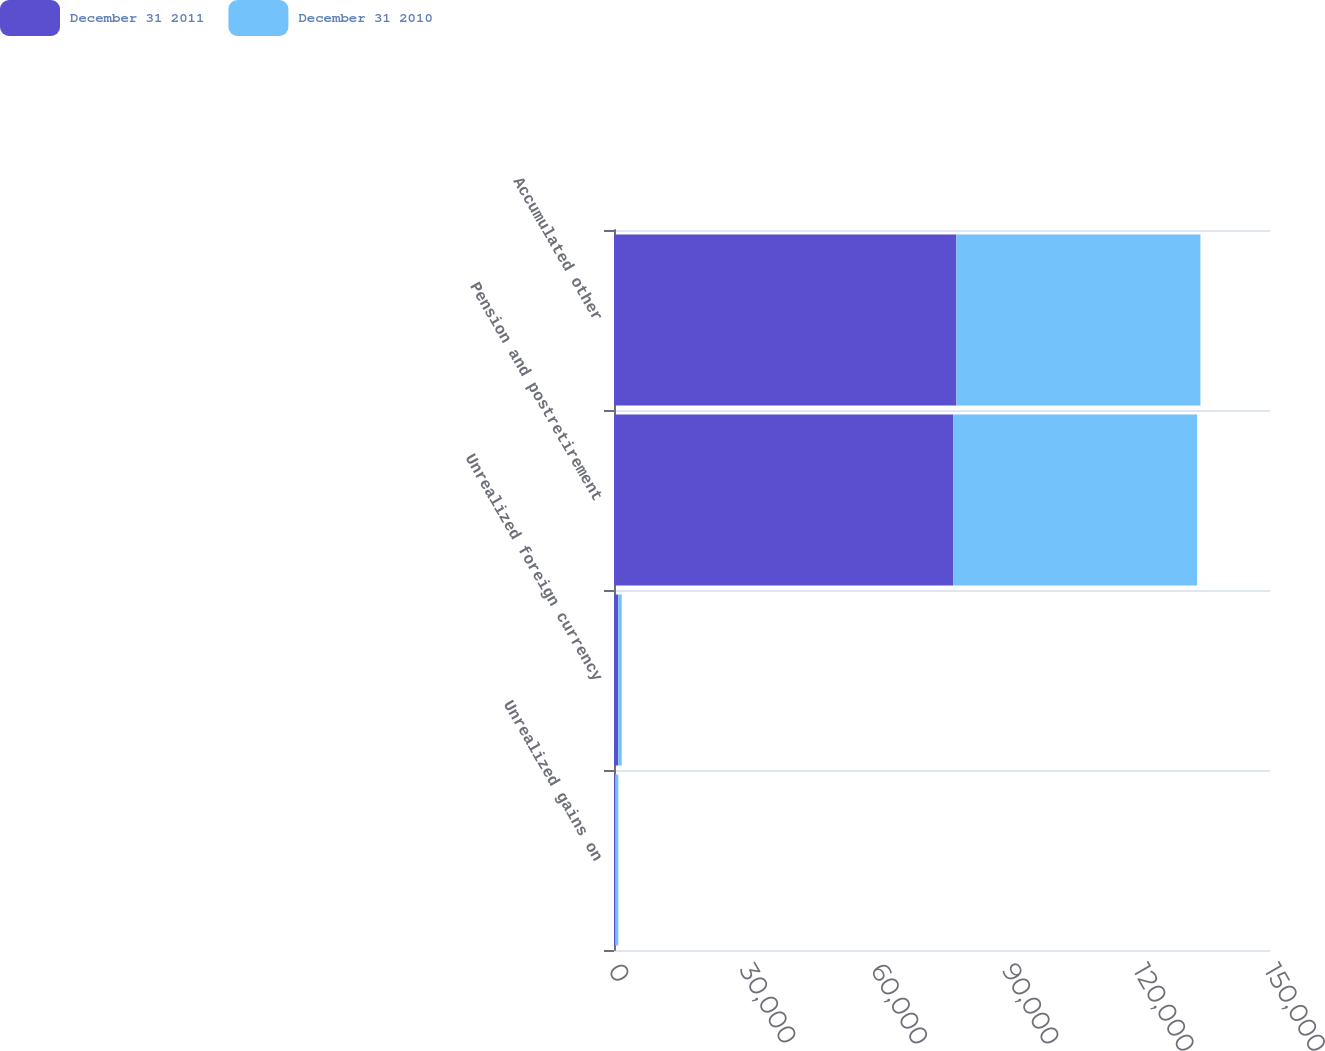<chart> <loc_0><loc_0><loc_500><loc_500><stacked_bar_chart><ecel><fcel>Unrealized gains on<fcel>Unrealized foreign currency<fcel>Pension and postretirement<fcel>Accumulated other<nl><fcel>December 31 2011<fcel>269<fcel>975<fcel>77581<fcel>78287<nl><fcel>December 31 2010<fcel>725<fcel>792<fcel>55736<fcel>55803<nl></chart> 